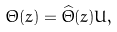Convert formula to latex. <formula><loc_0><loc_0><loc_500><loc_500>\Theta ( z ) = \widehat { \Theta } ( z ) U ,</formula> 